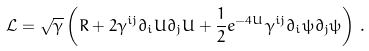<formula> <loc_0><loc_0><loc_500><loc_500>\mathcal { L } = \sqrt { \gamma } \left ( R + 2 \gamma ^ { i j } \partial _ { i } U \partial _ { j } U + \frac { 1 } { 2 } e ^ { - 4 U } \gamma ^ { i j } \partial _ { i } \psi \partial _ { j } \psi \right ) \, .</formula> 